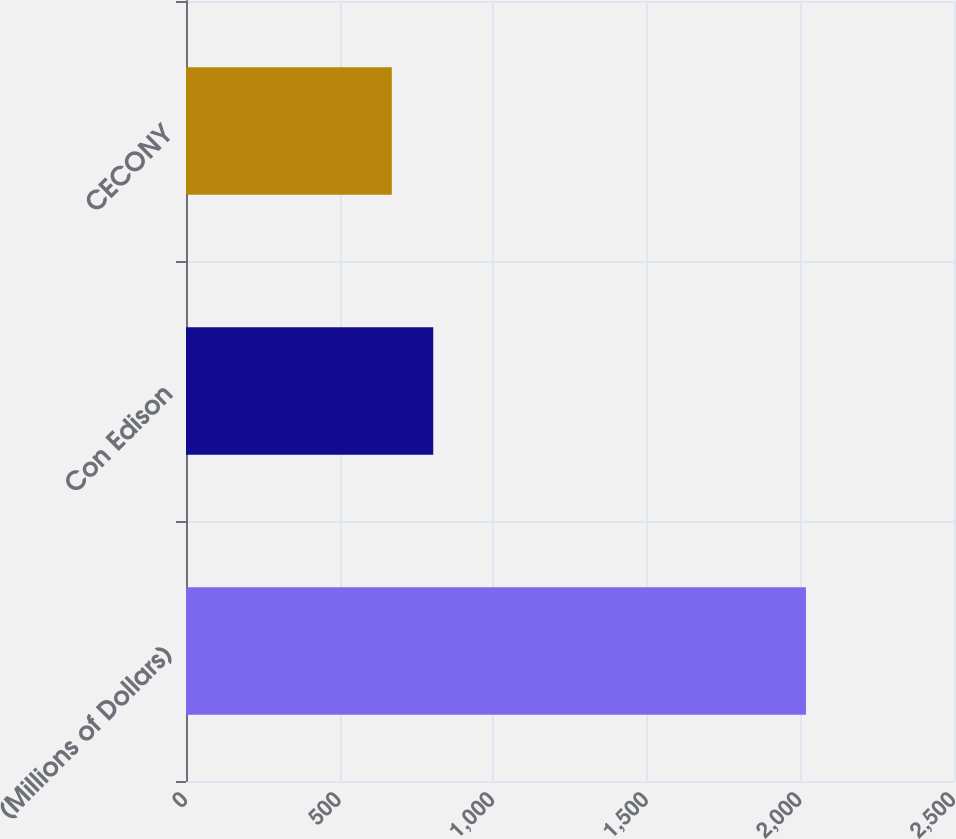Convert chart. <chart><loc_0><loc_0><loc_500><loc_500><bar_chart><fcel>(Millions of Dollars)<fcel>Con Edison<fcel>CECONY<nl><fcel>2018<fcel>804.8<fcel>670<nl></chart> 